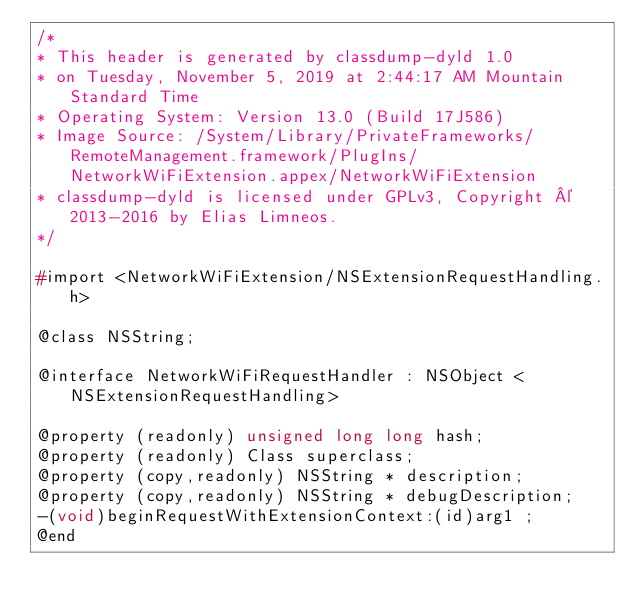Convert code to text. <code><loc_0><loc_0><loc_500><loc_500><_C_>/*
* This header is generated by classdump-dyld 1.0
* on Tuesday, November 5, 2019 at 2:44:17 AM Mountain Standard Time
* Operating System: Version 13.0 (Build 17J586)
* Image Source: /System/Library/PrivateFrameworks/RemoteManagement.framework/PlugIns/NetworkWiFiExtension.appex/NetworkWiFiExtension
* classdump-dyld is licensed under GPLv3, Copyright © 2013-2016 by Elias Limneos.
*/

#import <NetworkWiFiExtension/NSExtensionRequestHandling.h>

@class NSString;

@interface NetworkWiFiRequestHandler : NSObject <NSExtensionRequestHandling>

@property (readonly) unsigned long long hash; 
@property (readonly) Class superclass; 
@property (copy,readonly) NSString * description; 
@property (copy,readonly) NSString * debugDescription; 
-(void)beginRequestWithExtensionContext:(id)arg1 ;
@end

</code> 